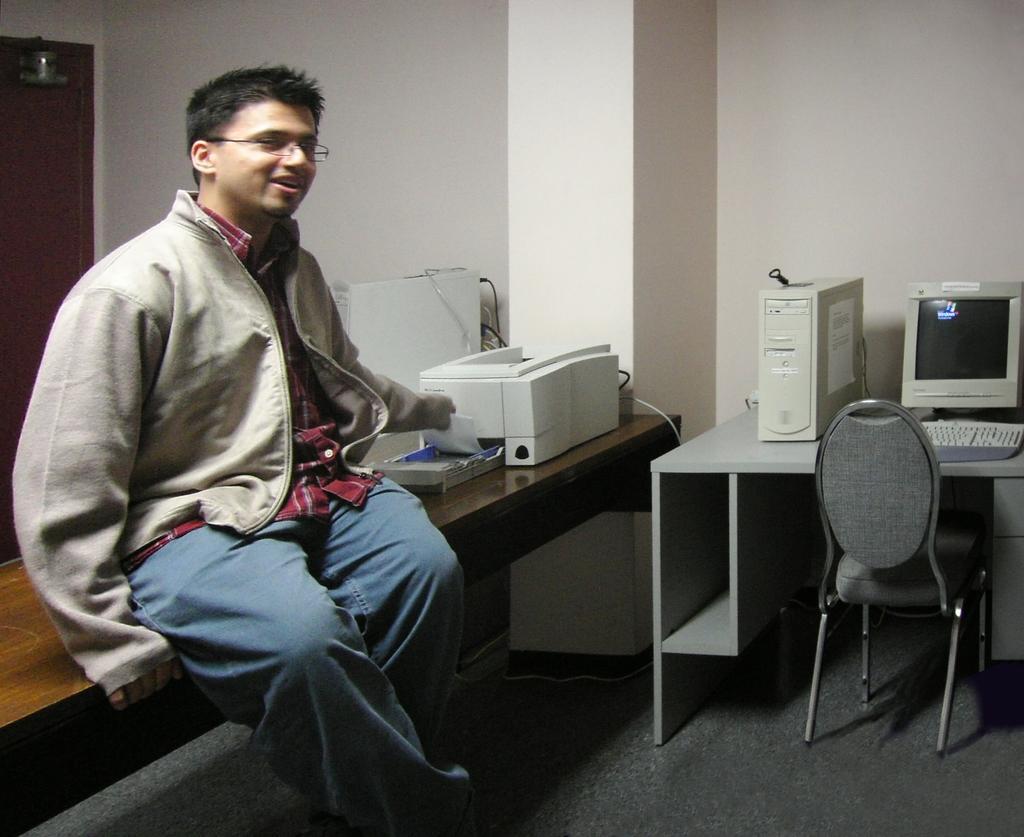Please provide a concise description of this image. In this image I can see a man is sitting on a table, I can also see he is wearing a specs. In the background I can see a computer system and a chair. 